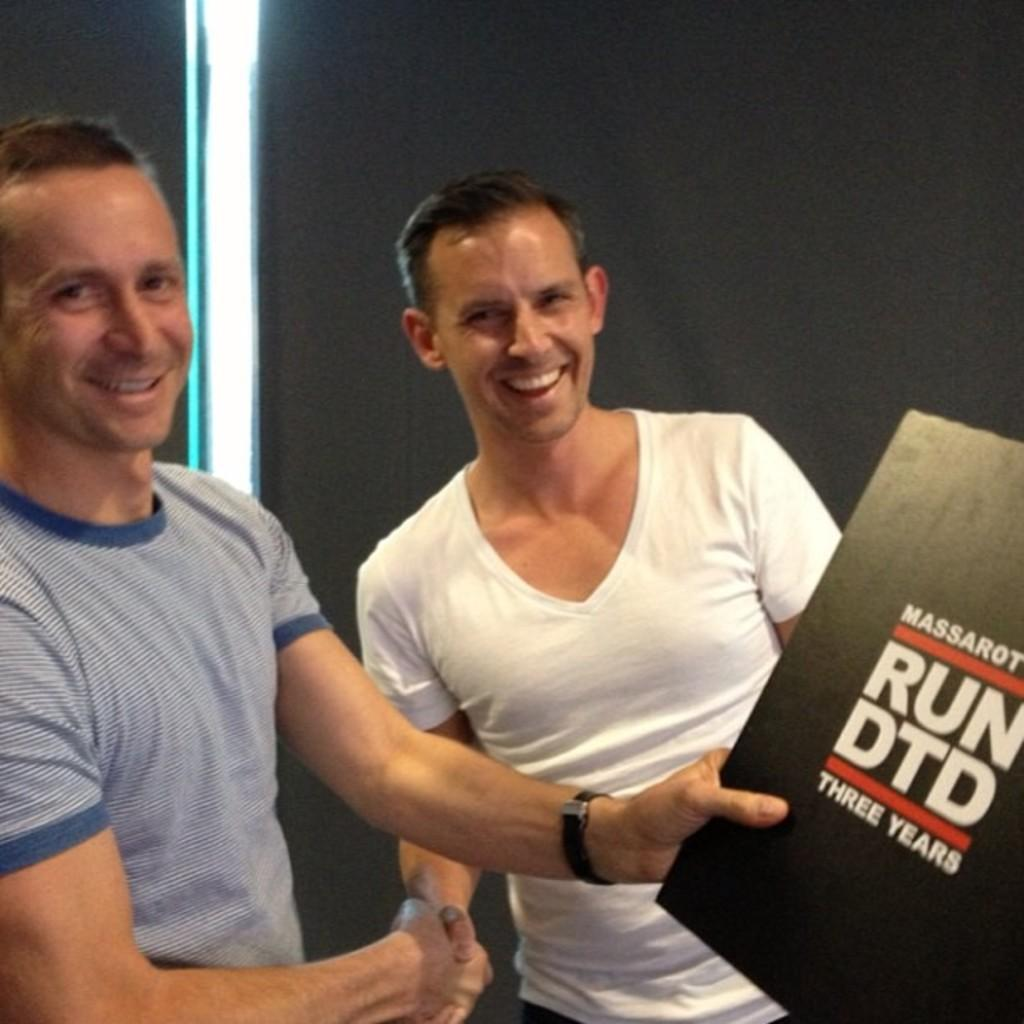How many persons are visible in the image? There are persons standing in the image. What are the persons holding in the image? The persons are holding a book. What can be seen in the background of the image? There is a wall in the background of the image. What type of lace can be seen on the book in the image? There is no lace visible on the book in the image. What is the texture of the wall in the background of the image? The texture of the wall cannot be determined from the image. What type of receipt is visible in the image? There is no receipt present in the image. 